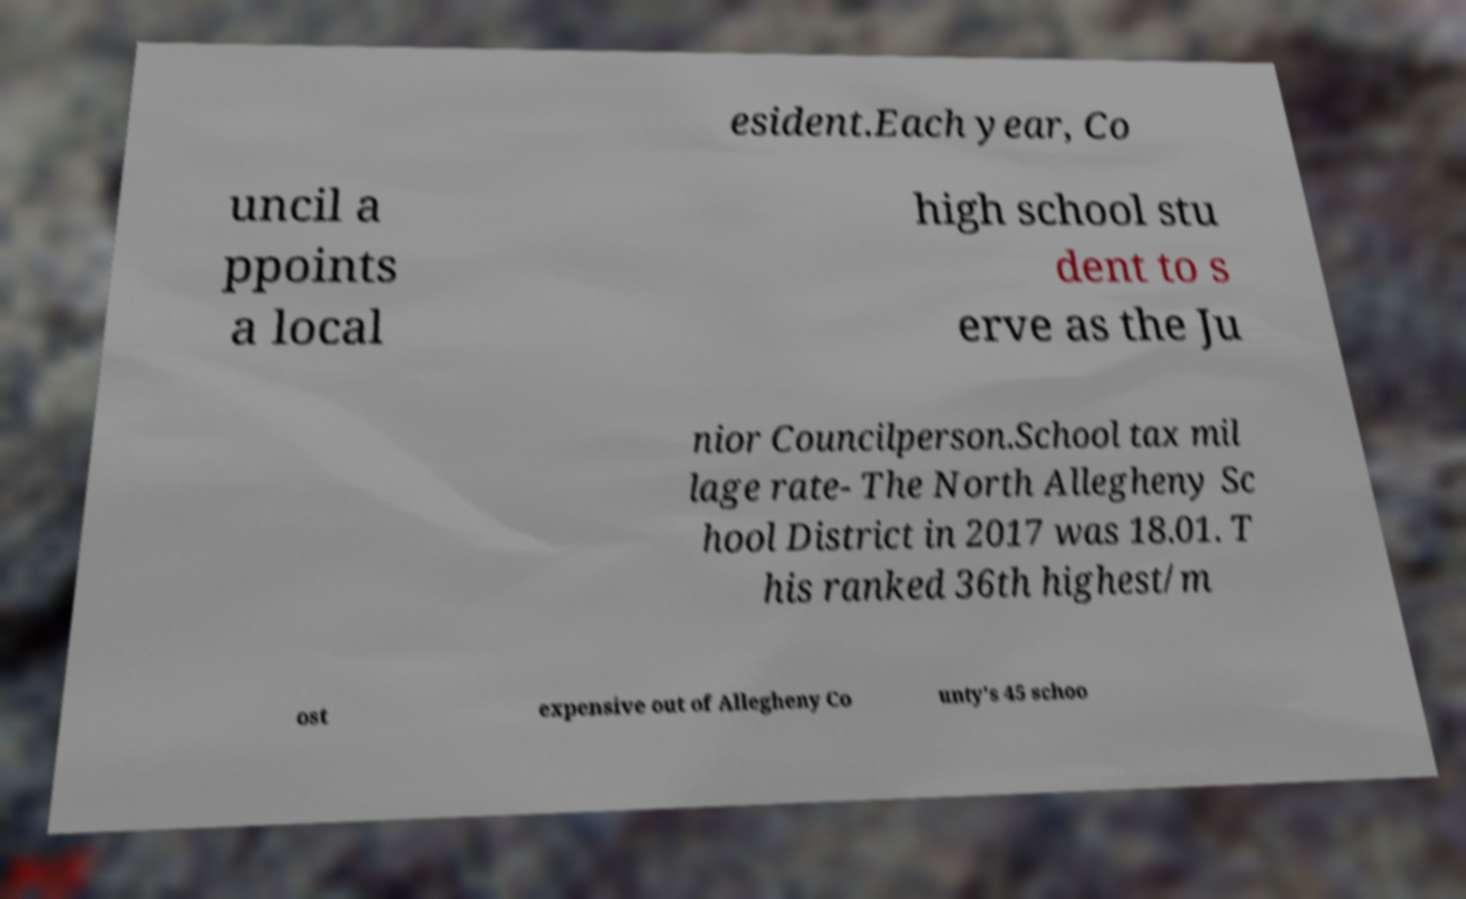Please identify and transcribe the text found in this image. esident.Each year, Co uncil a ppoints a local high school stu dent to s erve as the Ju nior Councilperson.School tax mil lage rate- The North Allegheny Sc hool District in 2017 was 18.01. T his ranked 36th highest/m ost expensive out of Allegheny Co unty's 45 schoo 